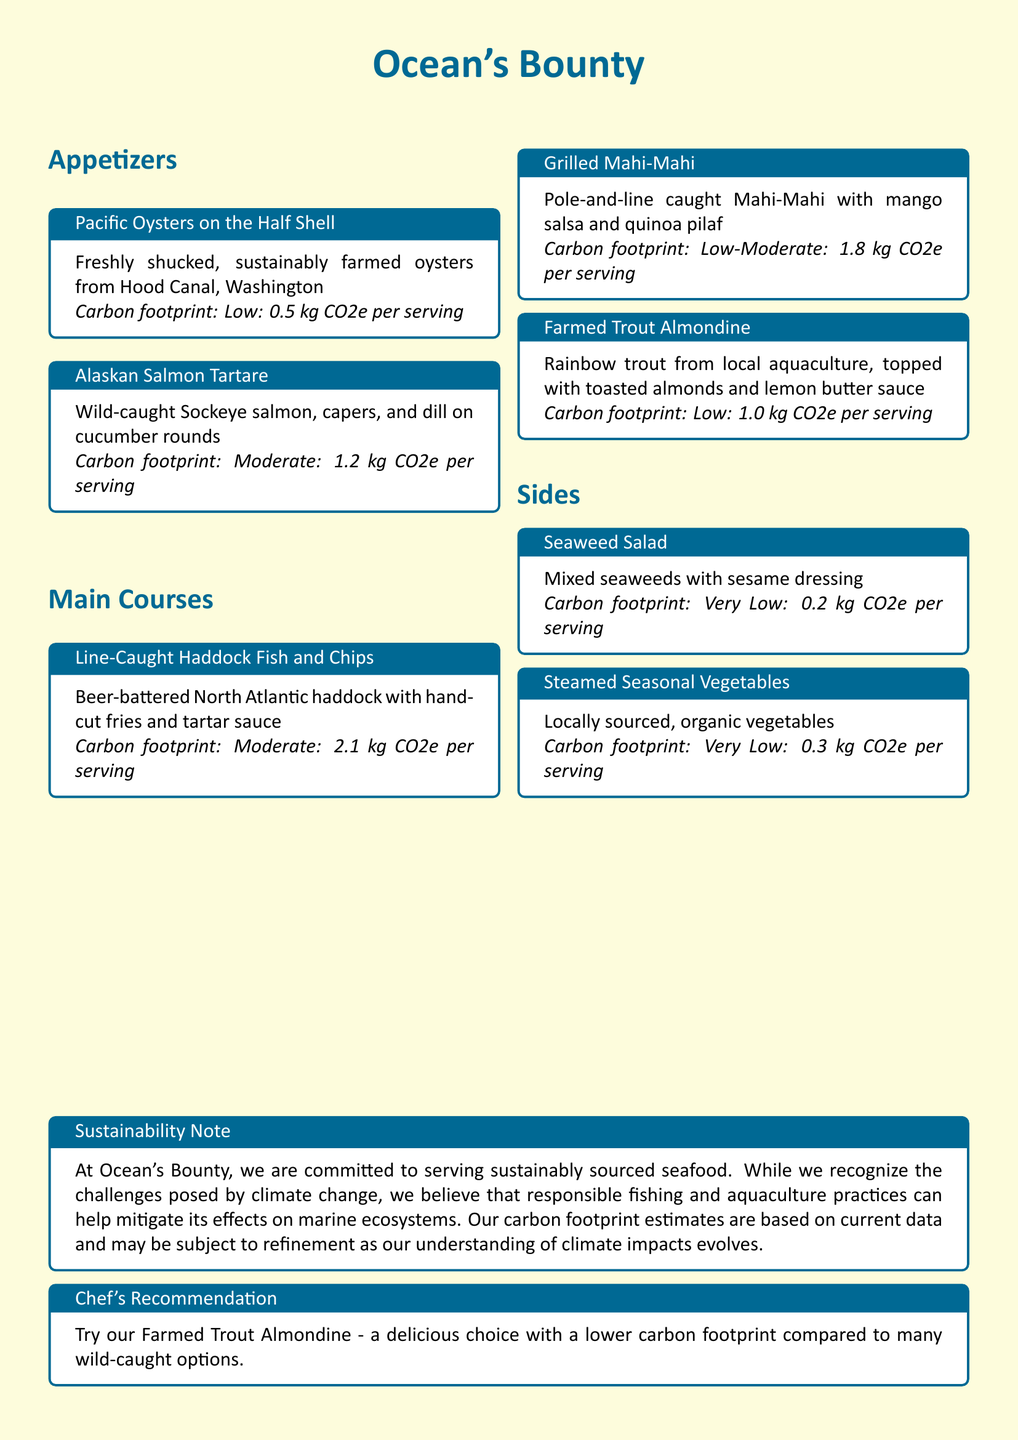What is the name of the restaurant? The restaurant is named "Ocean's Bounty," which is prominently displayed at the top of the menu.
Answer: Ocean's Bounty What type of oysters are served? The menu specifies that the oysters are "sustainably farmed" from Hood Canal, Washington.
Answer: Pacific Oysters What is the carbon footprint of Alaskan Salmon Tartare? The carbon footprint for this dish is mentioned as "Moderate: 1.2 kg CO2e per serving."
Answer: 1.2 kg CO2e Which dish has the lowest carbon footprint? The menu notes the carbon footprint for "Seaweed Salad" as "Very Low: 0.2 kg CO2e per serving," making it the lowest.
Answer: Seaweed Salad Which main course features quinoa? The dish "Grilled Mahi-Mahi" includes quinoa pilaf, indicating it is served with this side.
Answer: Grilled Mahi-Mahi Which dish is recommended by the chef? The menu includes a specific recommendation for a dish that is acknowledged for having a lower carbon footprint.
Answer: Farmed Trout Almondine How many kg CO2e does the Line-Caught Haddock Fish and Chips produce? The carbon footprint of this dish is provided as "Moderate: 2.1 kg CO2e per serving."
Answer: 2.1 kg CO2e What type of vegetables are served as a side? The menu indicates that the "Steamed Seasonal Vegetables" are "locally sourced" and "organic."
Answer: locally sourced, organic What farming practice is associated with the Mahi-Mahi dish? The menu mentions that Mahi-Mahi is "Pole-and-line caught," specifying the responsible fishing method used.
Answer: Pole-and-line caught 